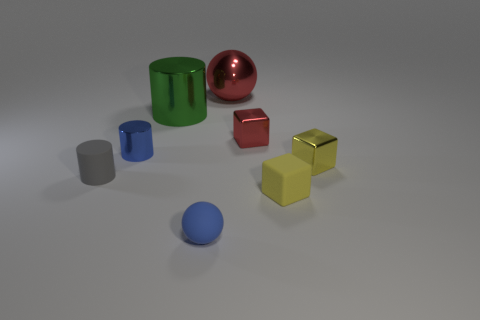Subtract all metallic cylinders. How many cylinders are left? 1 Subtract all gray cylinders. How many yellow blocks are left? 2 Subtract 1 cubes. How many cubes are left? 2 Add 1 small yellow cubes. How many objects exist? 9 Subtract all red blocks. How many blocks are left? 2 Subtract all blocks. How many objects are left? 5 Subtract all yellow cylinders. Subtract all brown spheres. How many cylinders are left? 3 Subtract all red cubes. Subtract all yellow blocks. How many objects are left? 5 Add 1 shiny spheres. How many shiny spheres are left? 2 Add 1 green cylinders. How many green cylinders exist? 2 